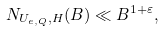Convert formula to latex. <formula><loc_0><loc_0><loc_500><loc_500>N _ { U _ { e , Q } , H } ( B ) \ll B ^ { 1 + \varepsilon } ,</formula> 